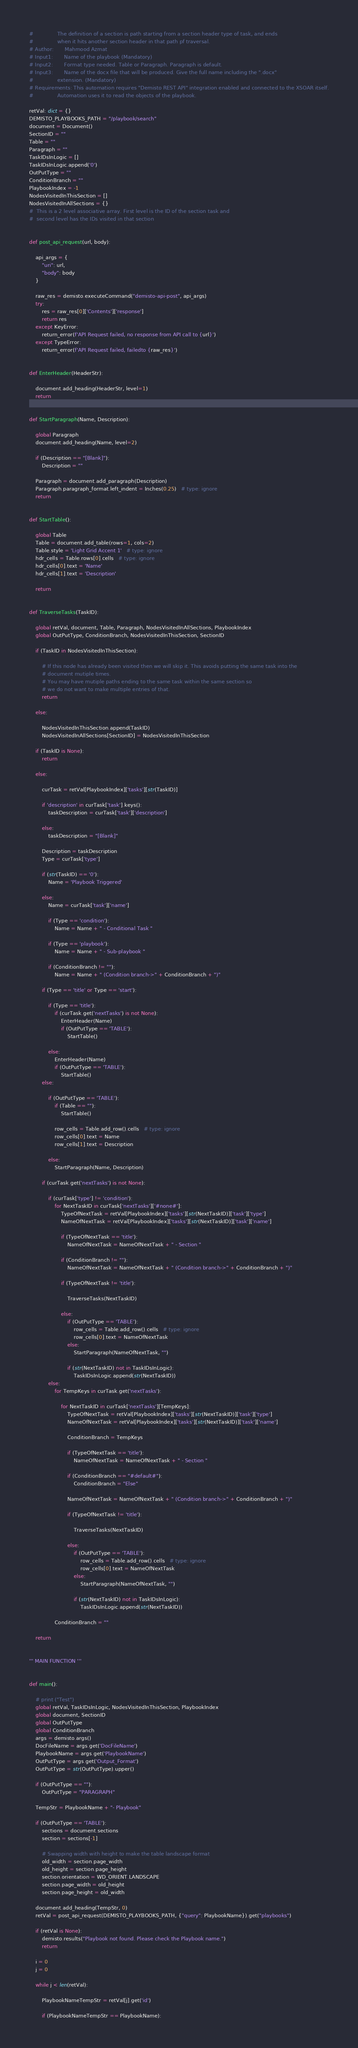<code> <loc_0><loc_0><loc_500><loc_500><_Python_>#               The definition of a section is path starting from a section header type of task, and ends
#               when it hits another section header in that path pf traversal.
# Author:       Mahmood Azmat
# Input1:       Name of the playbook (Mandatory)
# Input2:       Format type needed. Table or Paragraph. Paragraph is default.
# Input3:       Name of the docx file that will be produced. Give the full name including the ".docx"
#               extension. (Mandatory)
# Requirements: This automation requires "Demisto REST API" integration enabled and connected to the XSOAR itself.
#               Automation uses it to read the objects of the playbook.

retVal: dict = {}
DEMISTO_PLAYBOOKS_PATH = "/playbook/search"
document = Document()
SectionID = ""
Table = ""
Paragraph = ""
TaskIDsInLogic = []
TaskIDsInLogic.append('0')
OutPutType = ""
ConditionBranch = ""
PlaybookIndex = -1
NodesVisitedInThisSection = []
NodesVisitedInAllSections = {}
#  This is a 2 level associative array. First level is the ID of the section task and
#  second level has the IDs visited in that section


def post_api_request(url, body):

    api_args = {
        "uri": url,
        "body": body
    }

    raw_res = demisto.executeCommand("demisto-api-post", api_args)
    try:
        res = raw_res[0]['Contents']['response']
        return res
    except KeyError:
        return_error(f'API Request failed, no response from API call to {url}')
    except TypeError:
        return_error(f'API Request failed, failedto {raw_res}')


def EnterHeader(HeaderStr):

    document.add_heading(HeaderStr, level=1)
    return


def StartParagraph(Name, Description):

    global Paragraph
    document.add_heading(Name, level=2)

    if (Description == "[Blank]"):
        Description = ""

    Paragraph = document.add_paragraph(Description)
    Paragraph.paragraph_format.left_indent = Inches(0.25)   # type: ignore
    return


def StartTable():

    global Table
    Table = document.add_table(rows=1, cols=2)
    Table.style = 'Light Grid Accent 1'   # type: ignore
    hdr_cells = Table.rows[0].cells   # type: ignore
    hdr_cells[0].text = 'Name'
    hdr_cells[1].text = 'Description'

    return


def TraverseTasks(TaskID):

    global retVal, document, Table, Paragraph, NodesVisitedInAllSections, PlaybookIndex
    global OutPutType, ConditionBranch, NodesVisitedInThisSection, SectionID

    if (TaskID in NodesVisitedInThisSection):

        # If this node has already been visited then we will skip it. This avoids putting the same task into the
        # document mutiple times.
        # You may have mutiple paths ending to the same task within the same section so
        # we do not want to make multiple entries of that.
        return

    else:

        NodesVisitedInThisSection.append(TaskID)
        NodesVisitedInAllSections[SectionID] = NodesVisitedInThisSection

    if (TaskID is None):
        return

    else:

        curTask = retVal[PlaybookIndex]['tasks'][str(TaskID)]

        if 'description' in curTask['task'].keys():
            taskDescription = curTask['task']['description']

        else:
            taskDescription = "[Blank]"

        Description = taskDescription
        Type = curTask['type']

        if (str(TaskID) == '0'):
            Name = 'Playbook Triggered'

        else:
            Name = curTask['task']['name']

            if (Type == 'condition'):
                Name = Name + " - Conditional Task "

            if (Type == 'playbook'):
                Name = Name + " - Sub-playbook "

            if (ConditionBranch != ""):
                Name = Name + " (Condition branch->" + ConditionBranch + ")"

        if (Type == 'title' or Type == 'start'):

            if (Type == 'title'):
                if (curTask.get('nextTasks') is not None):
                    EnterHeader(Name)
                    if (OutPutType == 'TABLE'):
                        StartTable()

            else:
                EnterHeader(Name)
                if (OutPutType == 'TABLE'):
                    StartTable()
        else:

            if (OutPutType == 'TABLE'):
                if (Table == ""):
                    StartTable()

                row_cells = Table.add_row().cells   # type: ignore
                row_cells[0].text = Name
                row_cells[1].text = Description

            else:
                StartParagraph(Name, Description)

        if (curTask.get('nextTasks') is not None):

            if (curTask['type'] != 'condition'):
                for NextTaskID in curTask['nextTasks']['#none#']:
                    TypeOfNextTask = retVal[PlaybookIndex]['tasks'][str(NextTaskID)]['task']['type']
                    NameOfNextTask = retVal[PlaybookIndex]['tasks'][str(NextTaskID)]['task']['name']

                    if (TypeOfNextTask == 'title'):
                        NameOfNextTask = NameOfNextTask + " - Section "

                    if (ConditionBranch != ""):
                        NameOfNextTask = NameOfNextTask + " (Condition branch->" + ConditionBranch + ")"

                    if (TypeOfNextTask != 'title'):

                        TraverseTasks(NextTaskID)

                    else:
                        if (OutPutType == 'TABLE'):
                            row_cells = Table.add_row().cells   # type: ignore
                            row_cells[0].text = NameOfNextTask
                        else:
                            StartParagraph(NameOfNextTask, "")

                        if (str(NextTaskID) not in TaskIDsInLogic):
                            TaskIDsInLogic.append(str(NextTaskID))
            else:
                for TempKeys in curTask.get('nextTasks'):

                    for NextTaskID in curTask['nextTasks'][TempKeys]:
                        TypeOfNextTask = retVal[PlaybookIndex]['tasks'][str(NextTaskID)]['task']['type']
                        NameOfNextTask = retVal[PlaybookIndex]['tasks'][str(NextTaskID)]['task']['name']

                        ConditionBranch = TempKeys

                        if (TypeOfNextTask == 'title'):
                            NameOfNextTask = NameOfNextTask + " - Section "

                        if (ConditionBranch == "#default#"):
                            ConditionBranch = "Else"

                        NameOfNextTask = NameOfNextTask + " (Condition branch->" + ConditionBranch + ")"

                        if (TypeOfNextTask != 'title'):

                            TraverseTasks(NextTaskID)

                        else:
                            if (OutPutType == 'TABLE'):
                                row_cells = Table.add_row().cells   # type: ignore
                                row_cells[0].text = NameOfNextTask
                            else:
                                StartParagraph(NameOfNextTask, "")

                            if (str(NextTaskID) not in TaskIDsInLogic):
                                TaskIDsInLogic.append(str(NextTaskID))

                ConditionBranch = ""

    return


''' MAIN FUNCTION '''


def main():

    # print ("Test")
    global retVal, TaskIDsInLogic, NodesVisitedInThisSection, PlaybookIndex
    global document, SectionID
    global OutPutType
    global ConditionBranch
    args = demisto.args()
    DocFileName = args.get('DocFileName')
    PlaybookName = args.get('PlaybookName')
    OutPutType = args.get('Output_Format')
    OutPutType = str(OutPutType).upper()

    if (OutPutType == ""):
        OutPutType = "PARAGRAPH"

    TempStr = PlaybookName + "- Playbook"

    if (OutPutType == 'TABLE'):
        sections = document.sections
        section = sections[-1]

        # Swapping width with height to make the table landscape format
        old_width = section.page_width
        old_height = section.page_height
        section.orientation = WD_ORIENT.LANDSCAPE
        section.page_width = old_height
        section.page_height = old_width

    document.add_heading(TempStr, 0)
    retVal = post_api_request(DEMISTO_PLAYBOOKS_PATH, {"query": PlaybookName}).get("playbooks")

    if (retVal is None):
        demisto.results("Playbook not found. Please check the Playbook name.")
        return

    i = 0
    j = 0

    while j < len(retVal):

        PlaybookNameTempStr = retVal[j].get('id')

        if (PlaybookNameTempStr == PlaybookName):</code> 